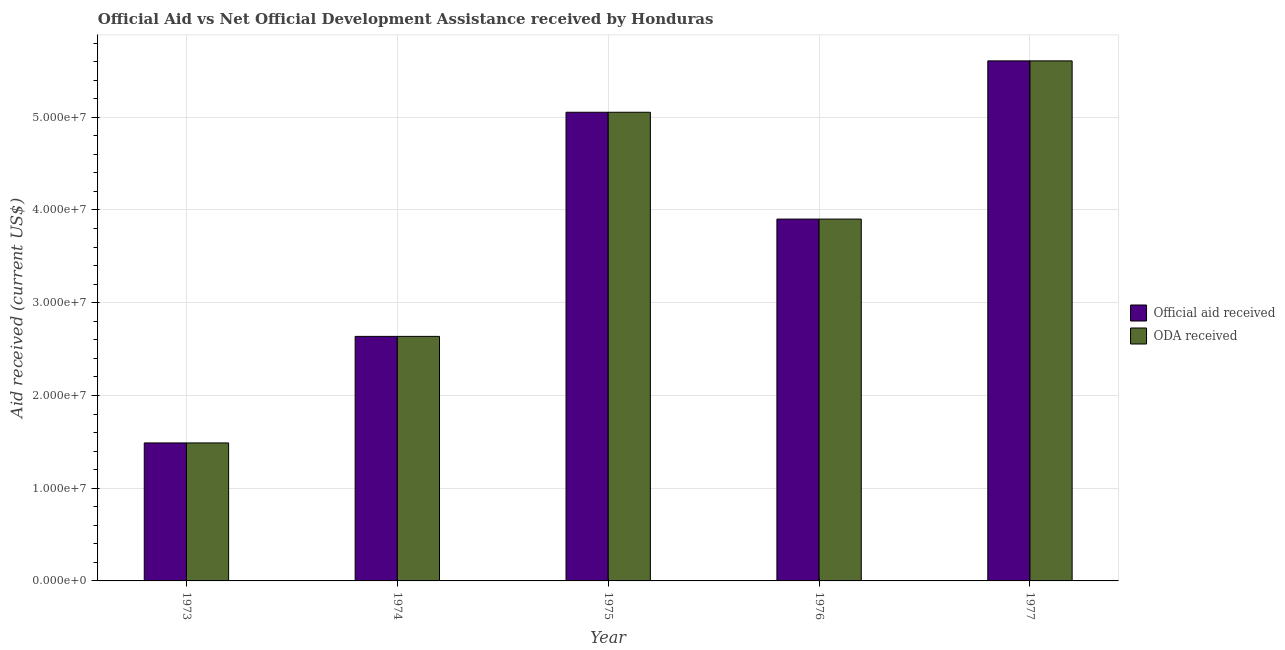How many different coloured bars are there?
Make the answer very short. 2. Are the number of bars per tick equal to the number of legend labels?
Offer a very short reply. Yes. How many bars are there on the 3rd tick from the right?
Ensure brevity in your answer.  2. What is the label of the 4th group of bars from the left?
Offer a very short reply. 1976. What is the official aid received in 1974?
Provide a short and direct response. 2.64e+07. Across all years, what is the maximum official aid received?
Ensure brevity in your answer.  5.61e+07. Across all years, what is the minimum official aid received?
Make the answer very short. 1.49e+07. What is the total oda received in the graph?
Provide a short and direct response. 1.87e+08. What is the difference between the official aid received in 1974 and that in 1975?
Your response must be concise. -2.42e+07. What is the difference between the oda received in 1974 and the official aid received in 1973?
Keep it short and to the point. 1.15e+07. What is the average oda received per year?
Your answer should be very brief. 3.74e+07. In how many years, is the official aid received greater than 42000000 US$?
Provide a succinct answer. 2. What is the ratio of the oda received in 1973 to that in 1975?
Provide a short and direct response. 0.29. Is the oda received in 1974 less than that in 1976?
Your answer should be very brief. Yes. What is the difference between the highest and the second highest official aid received?
Provide a succinct answer. 5.54e+06. What is the difference between the highest and the lowest oda received?
Your answer should be compact. 4.12e+07. In how many years, is the official aid received greater than the average official aid received taken over all years?
Your answer should be compact. 3. Is the sum of the oda received in 1975 and 1976 greater than the maximum official aid received across all years?
Offer a very short reply. Yes. What does the 1st bar from the left in 1974 represents?
Your answer should be very brief. Official aid received. What does the 1st bar from the right in 1977 represents?
Your answer should be compact. ODA received. Are all the bars in the graph horizontal?
Make the answer very short. No. How many years are there in the graph?
Make the answer very short. 5. Are the values on the major ticks of Y-axis written in scientific E-notation?
Ensure brevity in your answer.  Yes. Does the graph contain any zero values?
Keep it short and to the point. No. Does the graph contain grids?
Your response must be concise. Yes. Where does the legend appear in the graph?
Offer a terse response. Center right. How many legend labels are there?
Provide a short and direct response. 2. What is the title of the graph?
Your answer should be very brief. Official Aid vs Net Official Development Assistance received by Honduras . What is the label or title of the X-axis?
Provide a succinct answer. Year. What is the label or title of the Y-axis?
Give a very brief answer. Aid received (current US$). What is the Aid received (current US$) of Official aid received in 1973?
Ensure brevity in your answer.  1.49e+07. What is the Aid received (current US$) in ODA received in 1973?
Give a very brief answer. 1.49e+07. What is the Aid received (current US$) of Official aid received in 1974?
Keep it short and to the point. 2.64e+07. What is the Aid received (current US$) of ODA received in 1974?
Make the answer very short. 2.64e+07. What is the Aid received (current US$) of Official aid received in 1975?
Provide a short and direct response. 5.05e+07. What is the Aid received (current US$) in ODA received in 1975?
Give a very brief answer. 5.05e+07. What is the Aid received (current US$) in Official aid received in 1976?
Make the answer very short. 3.90e+07. What is the Aid received (current US$) of ODA received in 1976?
Provide a succinct answer. 3.90e+07. What is the Aid received (current US$) in Official aid received in 1977?
Make the answer very short. 5.61e+07. What is the Aid received (current US$) in ODA received in 1977?
Your response must be concise. 5.61e+07. Across all years, what is the maximum Aid received (current US$) of Official aid received?
Ensure brevity in your answer.  5.61e+07. Across all years, what is the maximum Aid received (current US$) in ODA received?
Offer a very short reply. 5.61e+07. Across all years, what is the minimum Aid received (current US$) of Official aid received?
Keep it short and to the point. 1.49e+07. Across all years, what is the minimum Aid received (current US$) in ODA received?
Offer a terse response. 1.49e+07. What is the total Aid received (current US$) of Official aid received in the graph?
Keep it short and to the point. 1.87e+08. What is the total Aid received (current US$) in ODA received in the graph?
Make the answer very short. 1.87e+08. What is the difference between the Aid received (current US$) of Official aid received in 1973 and that in 1974?
Keep it short and to the point. -1.15e+07. What is the difference between the Aid received (current US$) in ODA received in 1973 and that in 1974?
Offer a terse response. -1.15e+07. What is the difference between the Aid received (current US$) of Official aid received in 1973 and that in 1975?
Provide a short and direct response. -3.57e+07. What is the difference between the Aid received (current US$) in ODA received in 1973 and that in 1975?
Make the answer very short. -3.57e+07. What is the difference between the Aid received (current US$) in Official aid received in 1973 and that in 1976?
Your response must be concise. -2.41e+07. What is the difference between the Aid received (current US$) of ODA received in 1973 and that in 1976?
Ensure brevity in your answer.  -2.41e+07. What is the difference between the Aid received (current US$) of Official aid received in 1973 and that in 1977?
Your response must be concise. -4.12e+07. What is the difference between the Aid received (current US$) of ODA received in 1973 and that in 1977?
Your response must be concise. -4.12e+07. What is the difference between the Aid received (current US$) in Official aid received in 1974 and that in 1975?
Make the answer very short. -2.42e+07. What is the difference between the Aid received (current US$) of ODA received in 1974 and that in 1975?
Make the answer very short. -2.42e+07. What is the difference between the Aid received (current US$) of Official aid received in 1974 and that in 1976?
Your answer should be very brief. -1.26e+07. What is the difference between the Aid received (current US$) of ODA received in 1974 and that in 1976?
Your answer should be compact. -1.26e+07. What is the difference between the Aid received (current US$) in Official aid received in 1974 and that in 1977?
Provide a short and direct response. -2.97e+07. What is the difference between the Aid received (current US$) in ODA received in 1974 and that in 1977?
Your answer should be very brief. -2.97e+07. What is the difference between the Aid received (current US$) of Official aid received in 1975 and that in 1976?
Make the answer very short. 1.15e+07. What is the difference between the Aid received (current US$) of ODA received in 1975 and that in 1976?
Offer a very short reply. 1.15e+07. What is the difference between the Aid received (current US$) of Official aid received in 1975 and that in 1977?
Keep it short and to the point. -5.54e+06. What is the difference between the Aid received (current US$) of ODA received in 1975 and that in 1977?
Keep it short and to the point. -5.54e+06. What is the difference between the Aid received (current US$) in Official aid received in 1976 and that in 1977?
Make the answer very short. -1.71e+07. What is the difference between the Aid received (current US$) of ODA received in 1976 and that in 1977?
Your answer should be compact. -1.71e+07. What is the difference between the Aid received (current US$) of Official aid received in 1973 and the Aid received (current US$) of ODA received in 1974?
Offer a terse response. -1.15e+07. What is the difference between the Aid received (current US$) in Official aid received in 1973 and the Aid received (current US$) in ODA received in 1975?
Give a very brief answer. -3.57e+07. What is the difference between the Aid received (current US$) of Official aid received in 1973 and the Aid received (current US$) of ODA received in 1976?
Your answer should be very brief. -2.41e+07. What is the difference between the Aid received (current US$) in Official aid received in 1973 and the Aid received (current US$) in ODA received in 1977?
Your answer should be very brief. -4.12e+07. What is the difference between the Aid received (current US$) in Official aid received in 1974 and the Aid received (current US$) in ODA received in 1975?
Make the answer very short. -2.42e+07. What is the difference between the Aid received (current US$) in Official aid received in 1974 and the Aid received (current US$) in ODA received in 1976?
Your response must be concise. -1.26e+07. What is the difference between the Aid received (current US$) of Official aid received in 1974 and the Aid received (current US$) of ODA received in 1977?
Your response must be concise. -2.97e+07. What is the difference between the Aid received (current US$) in Official aid received in 1975 and the Aid received (current US$) in ODA received in 1976?
Keep it short and to the point. 1.15e+07. What is the difference between the Aid received (current US$) in Official aid received in 1975 and the Aid received (current US$) in ODA received in 1977?
Give a very brief answer. -5.54e+06. What is the difference between the Aid received (current US$) of Official aid received in 1976 and the Aid received (current US$) of ODA received in 1977?
Your answer should be very brief. -1.71e+07. What is the average Aid received (current US$) in Official aid received per year?
Offer a terse response. 3.74e+07. What is the average Aid received (current US$) of ODA received per year?
Provide a short and direct response. 3.74e+07. In the year 1976, what is the difference between the Aid received (current US$) in Official aid received and Aid received (current US$) in ODA received?
Ensure brevity in your answer.  0. In the year 1977, what is the difference between the Aid received (current US$) of Official aid received and Aid received (current US$) of ODA received?
Ensure brevity in your answer.  0. What is the ratio of the Aid received (current US$) in Official aid received in 1973 to that in 1974?
Your response must be concise. 0.56. What is the ratio of the Aid received (current US$) in ODA received in 1973 to that in 1974?
Offer a terse response. 0.56. What is the ratio of the Aid received (current US$) of Official aid received in 1973 to that in 1975?
Your response must be concise. 0.29. What is the ratio of the Aid received (current US$) in ODA received in 1973 to that in 1975?
Offer a terse response. 0.29. What is the ratio of the Aid received (current US$) in Official aid received in 1973 to that in 1976?
Your response must be concise. 0.38. What is the ratio of the Aid received (current US$) in ODA received in 1973 to that in 1976?
Provide a succinct answer. 0.38. What is the ratio of the Aid received (current US$) in Official aid received in 1973 to that in 1977?
Provide a succinct answer. 0.27. What is the ratio of the Aid received (current US$) in ODA received in 1973 to that in 1977?
Keep it short and to the point. 0.27. What is the ratio of the Aid received (current US$) of Official aid received in 1974 to that in 1975?
Make the answer very short. 0.52. What is the ratio of the Aid received (current US$) of ODA received in 1974 to that in 1975?
Provide a short and direct response. 0.52. What is the ratio of the Aid received (current US$) in Official aid received in 1974 to that in 1976?
Provide a short and direct response. 0.68. What is the ratio of the Aid received (current US$) in ODA received in 1974 to that in 1976?
Your response must be concise. 0.68. What is the ratio of the Aid received (current US$) of Official aid received in 1974 to that in 1977?
Your answer should be compact. 0.47. What is the ratio of the Aid received (current US$) of ODA received in 1974 to that in 1977?
Offer a terse response. 0.47. What is the ratio of the Aid received (current US$) in Official aid received in 1975 to that in 1976?
Give a very brief answer. 1.3. What is the ratio of the Aid received (current US$) of ODA received in 1975 to that in 1976?
Offer a very short reply. 1.3. What is the ratio of the Aid received (current US$) of Official aid received in 1975 to that in 1977?
Provide a short and direct response. 0.9. What is the ratio of the Aid received (current US$) of ODA received in 1975 to that in 1977?
Make the answer very short. 0.9. What is the ratio of the Aid received (current US$) of Official aid received in 1976 to that in 1977?
Offer a terse response. 0.7. What is the ratio of the Aid received (current US$) in ODA received in 1976 to that in 1977?
Your answer should be very brief. 0.7. What is the difference between the highest and the second highest Aid received (current US$) in Official aid received?
Your answer should be very brief. 5.54e+06. What is the difference between the highest and the second highest Aid received (current US$) of ODA received?
Provide a succinct answer. 5.54e+06. What is the difference between the highest and the lowest Aid received (current US$) in Official aid received?
Provide a succinct answer. 4.12e+07. What is the difference between the highest and the lowest Aid received (current US$) in ODA received?
Your answer should be compact. 4.12e+07. 